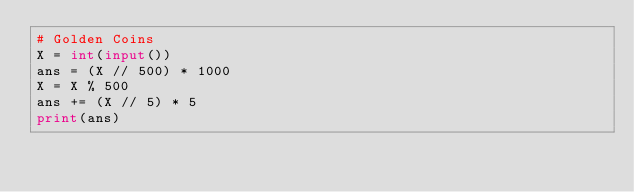Convert code to text. <code><loc_0><loc_0><loc_500><loc_500><_Python_># Golden Coins
X = int(input())
ans = (X // 500) * 1000
X = X % 500
ans += (X // 5) * 5
print(ans)
</code> 